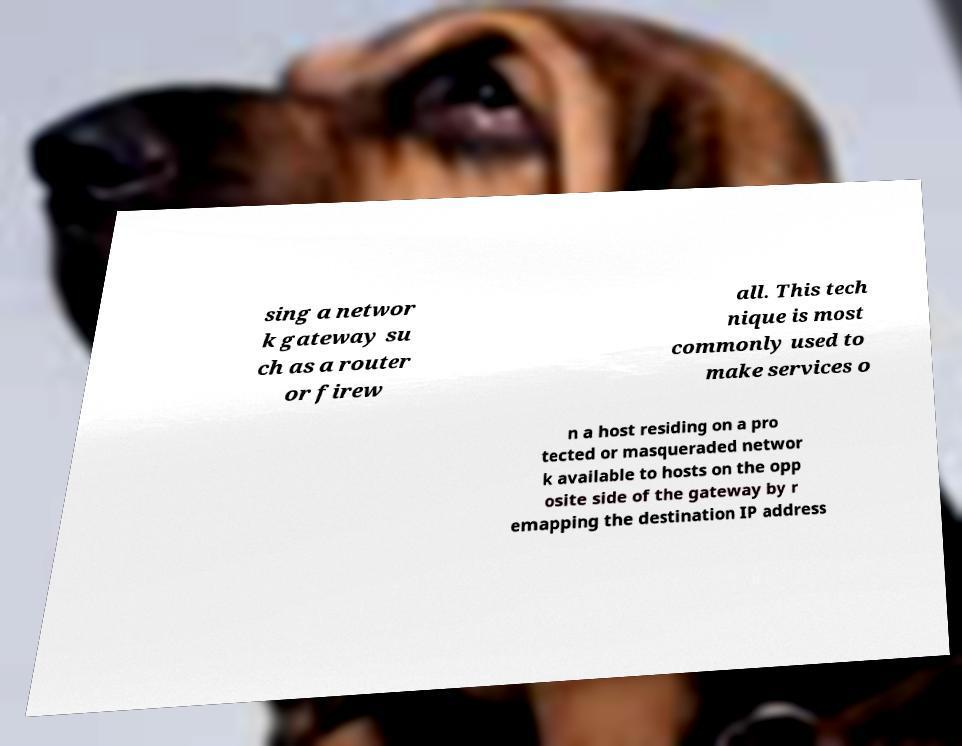Can you read and provide the text displayed in the image?This photo seems to have some interesting text. Can you extract and type it out for me? sing a networ k gateway su ch as a router or firew all. This tech nique is most commonly used to make services o n a host residing on a pro tected or masqueraded networ k available to hosts on the opp osite side of the gateway by r emapping the destination IP address 